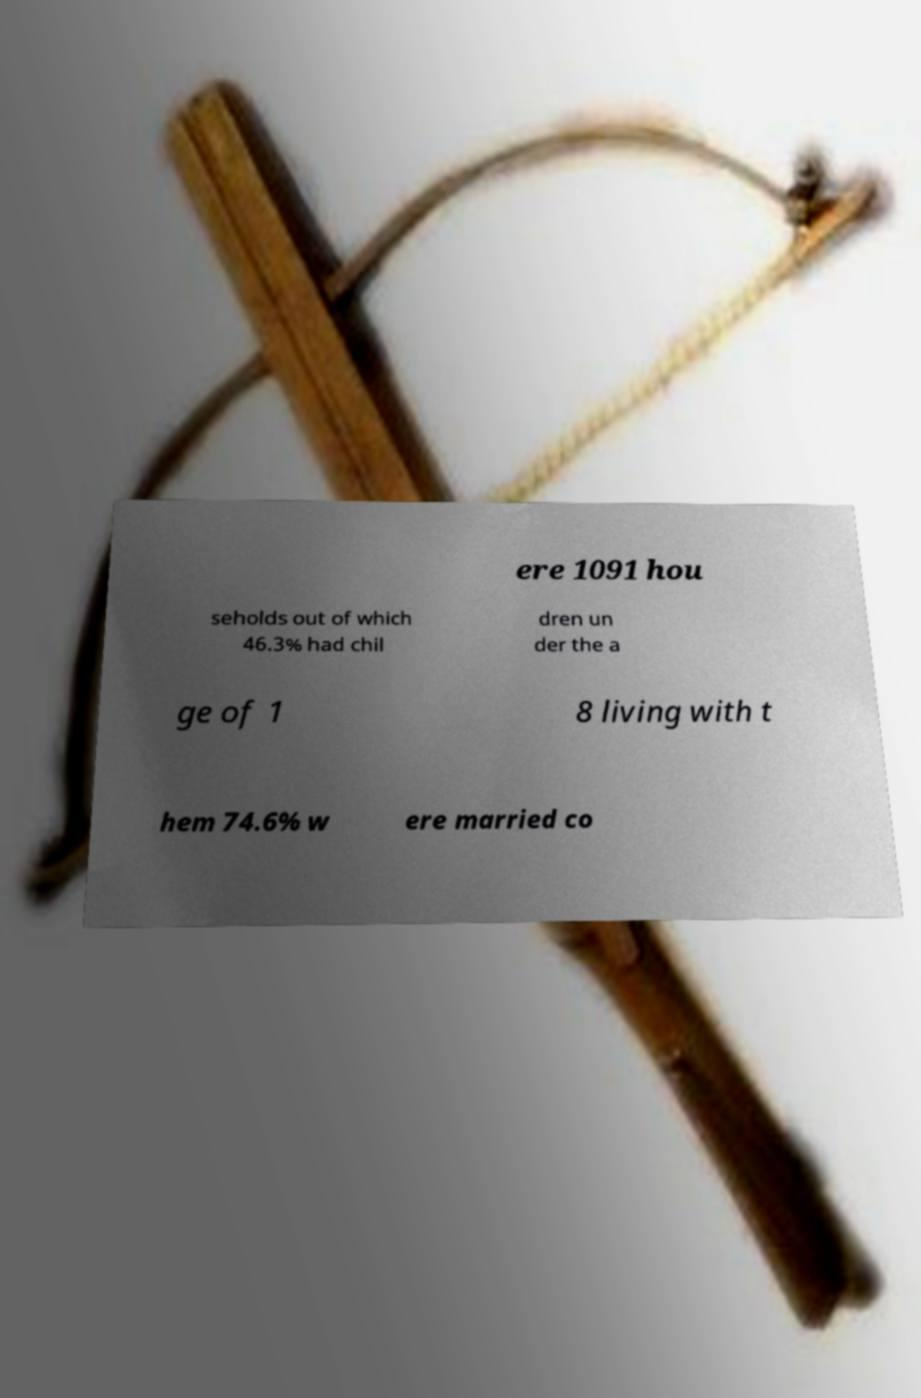Can you read and provide the text displayed in the image?This photo seems to have some interesting text. Can you extract and type it out for me? ere 1091 hou seholds out of which 46.3% had chil dren un der the a ge of 1 8 living with t hem 74.6% w ere married co 